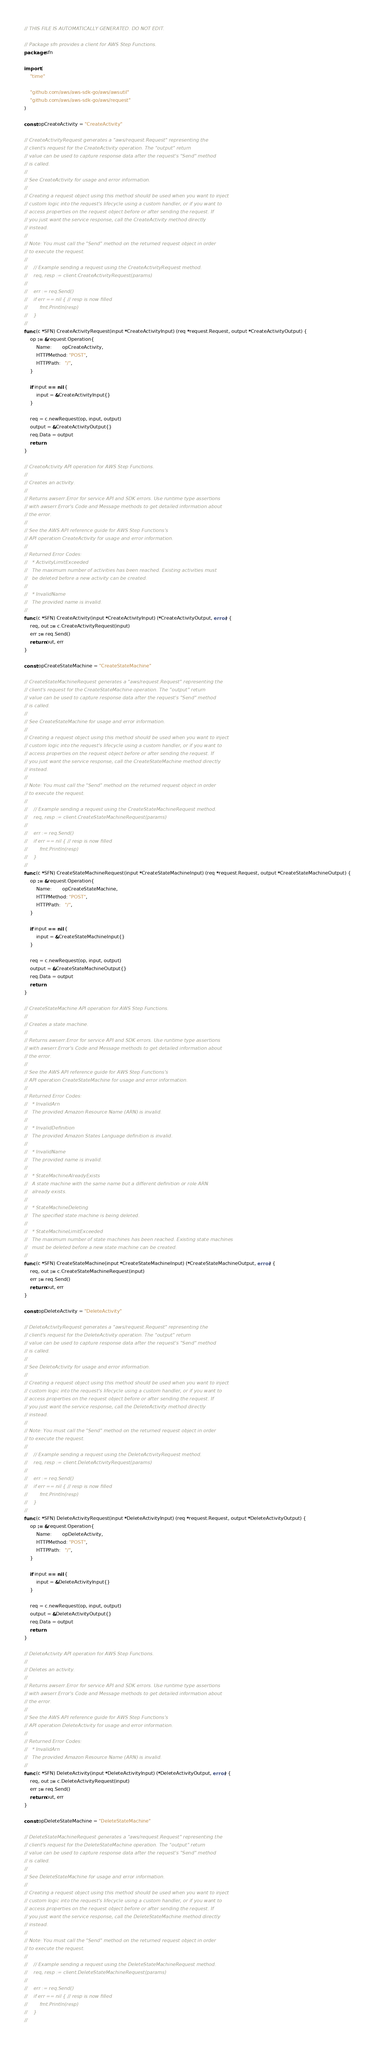<code> <loc_0><loc_0><loc_500><loc_500><_Go_>// THIS FILE IS AUTOMATICALLY GENERATED. DO NOT EDIT.

// Package sfn provides a client for AWS Step Functions.
package sfn

import (
	"time"

	"github.com/aws/aws-sdk-go/aws/awsutil"
	"github.com/aws/aws-sdk-go/aws/request"
)

const opCreateActivity = "CreateActivity"

// CreateActivityRequest generates a "aws/request.Request" representing the
// client's request for the CreateActivity operation. The "output" return
// value can be used to capture response data after the request's "Send" method
// is called.
//
// See CreateActivity for usage and error information.
//
// Creating a request object using this method should be used when you want to inject
// custom logic into the request's lifecycle using a custom handler, or if you want to
// access properties on the request object before or after sending the request. If
// you just want the service response, call the CreateActivity method directly
// instead.
//
// Note: You must call the "Send" method on the returned request object in order
// to execute the request.
//
//    // Example sending a request using the CreateActivityRequest method.
//    req, resp := client.CreateActivityRequest(params)
//
//    err := req.Send()
//    if err == nil { // resp is now filled
//        fmt.Println(resp)
//    }
//
func (c *SFN) CreateActivityRequest(input *CreateActivityInput) (req *request.Request, output *CreateActivityOutput) {
	op := &request.Operation{
		Name:       opCreateActivity,
		HTTPMethod: "POST",
		HTTPPath:   "/",
	}

	if input == nil {
		input = &CreateActivityInput{}
	}

	req = c.newRequest(op, input, output)
	output = &CreateActivityOutput{}
	req.Data = output
	return
}

// CreateActivity API operation for AWS Step Functions.
//
// Creates an activity.
//
// Returns awserr.Error for service API and SDK errors. Use runtime type assertions
// with awserr.Error's Code and Message methods to get detailed information about
// the error.
//
// See the AWS API reference guide for AWS Step Functions's
// API operation CreateActivity for usage and error information.
//
// Returned Error Codes:
//   * ActivityLimitExceeded
//   The maximum number of activities has been reached. Existing activities must
//   be deleted before a new activity can be created.
//
//   * InvalidName
//   The provided name is invalid.
//
func (c *SFN) CreateActivity(input *CreateActivityInput) (*CreateActivityOutput, error) {
	req, out := c.CreateActivityRequest(input)
	err := req.Send()
	return out, err
}

const opCreateStateMachine = "CreateStateMachine"

// CreateStateMachineRequest generates a "aws/request.Request" representing the
// client's request for the CreateStateMachine operation. The "output" return
// value can be used to capture response data after the request's "Send" method
// is called.
//
// See CreateStateMachine for usage and error information.
//
// Creating a request object using this method should be used when you want to inject
// custom logic into the request's lifecycle using a custom handler, or if you want to
// access properties on the request object before or after sending the request. If
// you just want the service response, call the CreateStateMachine method directly
// instead.
//
// Note: You must call the "Send" method on the returned request object in order
// to execute the request.
//
//    // Example sending a request using the CreateStateMachineRequest method.
//    req, resp := client.CreateStateMachineRequest(params)
//
//    err := req.Send()
//    if err == nil { // resp is now filled
//        fmt.Println(resp)
//    }
//
func (c *SFN) CreateStateMachineRequest(input *CreateStateMachineInput) (req *request.Request, output *CreateStateMachineOutput) {
	op := &request.Operation{
		Name:       opCreateStateMachine,
		HTTPMethod: "POST",
		HTTPPath:   "/",
	}

	if input == nil {
		input = &CreateStateMachineInput{}
	}

	req = c.newRequest(op, input, output)
	output = &CreateStateMachineOutput{}
	req.Data = output
	return
}

// CreateStateMachine API operation for AWS Step Functions.
//
// Creates a state machine.
//
// Returns awserr.Error for service API and SDK errors. Use runtime type assertions
// with awserr.Error's Code and Message methods to get detailed information about
// the error.
//
// See the AWS API reference guide for AWS Step Functions's
// API operation CreateStateMachine for usage and error information.
//
// Returned Error Codes:
//   * InvalidArn
//   The provided Amazon Resource Name (ARN) is invalid.
//
//   * InvalidDefinition
//   The provided Amazon States Language definition is invalid.
//
//   * InvalidName
//   The provided name is invalid.
//
//   * StateMachineAlreadyExists
//   A state machine with the same name but a different definition or role ARN
//   already exists.
//
//   * StateMachineDeleting
//   The specified state machine is being deleted.
//
//   * StateMachineLimitExceeded
//   The maximum number of state machines has been reached. Existing state machines
//   must be deleted before a new state machine can be created.
//
func (c *SFN) CreateStateMachine(input *CreateStateMachineInput) (*CreateStateMachineOutput, error) {
	req, out := c.CreateStateMachineRequest(input)
	err := req.Send()
	return out, err
}

const opDeleteActivity = "DeleteActivity"

// DeleteActivityRequest generates a "aws/request.Request" representing the
// client's request for the DeleteActivity operation. The "output" return
// value can be used to capture response data after the request's "Send" method
// is called.
//
// See DeleteActivity for usage and error information.
//
// Creating a request object using this method should be used when you want to inject
// custom logic into the request's lifecycle using a custom handler, or if you want to
// access properties on the request object before or after sending the request. If
// you just want the service response, call the DeleteActivity method directly
// instead.
//
// Note: You must call the "Send" method on the returned request object in order
// to execute the request.
//
//    // Example sending a request using the DeleteActivityRequest method.
//    req, resp := client.DeleteActivityRequest(params)
//
//    err := req.Send()
//    if err == nil { // resp is now filled
//        fmt.Println(resp)
//    }
//
func (c *SFN) DeleteActivityRequest(input *DeleteActivityInput) (req *request.Request, output *DeleteActivityOutput) {
	op := &request.Operation{
		Name:       opDeleteActivity,
		HTTPMethod: "POST",
		HTTPPath:   "/",
	}

	if input == nil {
		input = &DeleteActivityInput{}
	}

	req = c.newRequest(op, input, output)
	output = &DeleteActivityOutput{}
	req.Data = output
	return
}

// DeleteActivity API operation for AWS Step Functions.
//
// Deletes an activity.
//
// Returns awserr.Error for service API and SDK errors. Use runtime type assertions
// with awserr.Error's Code and Message methods to get detailed information about
// the error.
//
// See the AWS API reference guide for AWS Step Functions's
// API operation DeleteActivity for usage and error information.
//
// Returned Error Codes:
//   * InvalidArn
//   The provided Amazon Resource Name (ARN) is invalid.
//
func (c *SFN) DeleteActivity(input *DeleteActivityInput) (*DeleteActivityOutput, error) {
	req, out := c.DeleteActivityRequest(input)
	err := req.Send()
	return out, err
}

const opDeleteStateMachine = "DeleteStateMachine"

// DeleteStateMachineRequest generates a "aws/request.Request" representing the
// client's request for the DeleteStateMachine operation. The "output" return
// value can be used to capture response data after the request's "Send" method
// is called.
//
// See DeleteStateMachine for usage and error information.
//
// Creating a request object using this method should be used when you want to inject
// custom logic into the request's lifecycle using a custom handler, or if you want to
// access properties on the request object before or after sending the request. If
// you just want the service response, call the DeleteStateMachine method directly
// instead.
//
// Note: You must call the "Send" method on the returned request object in order
// to execute the request.
//
//    // Example sending a request using the DeleteStateMachineRequest method.
//    req, resp := client.DeleteStateMachineRequest(params)
//
//    err := req.Send()
//    if err == nil { // resp is now filled
//        fmt.Println(resp)
//    }
//</code> 